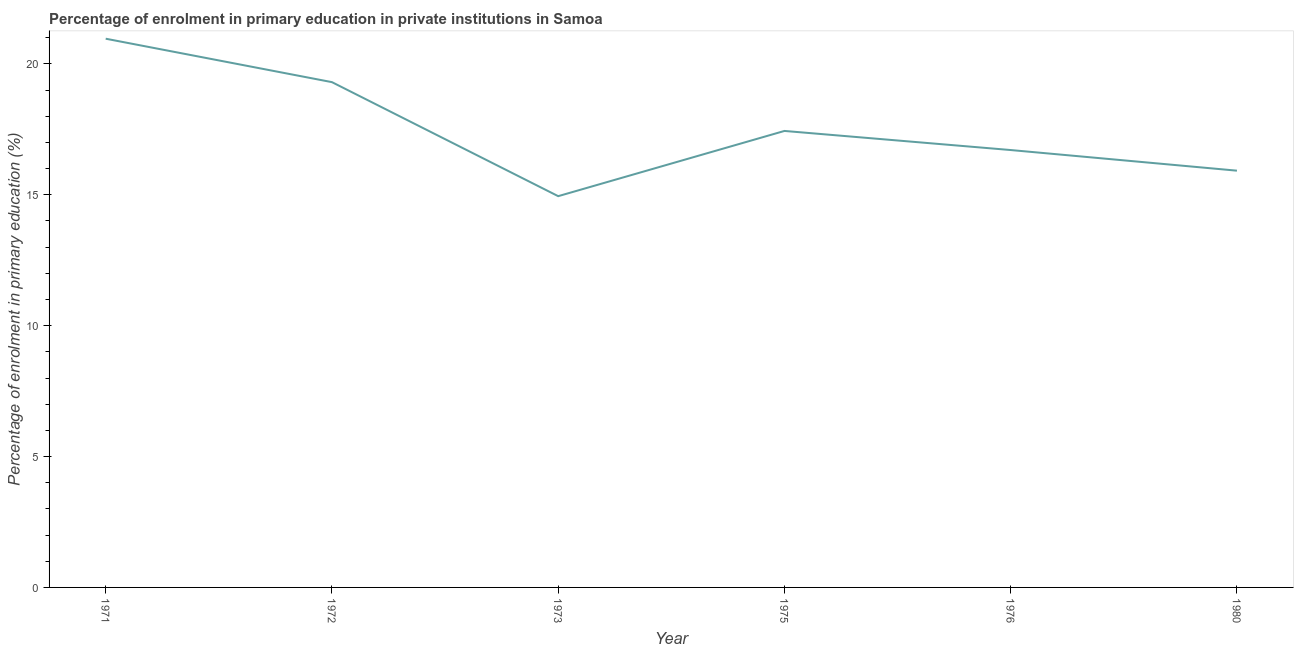What is the enrolment percentage in primary education in 1975?
Keep it short and to the point. 17.44. Across all years, what is the maximum enrolment percentage in primary education?
Provide a short and direct response. 20.96. Across all years, what is the minimum enrolment percentage in primary education?
Offer a terse response. 14.95. In which year was the enrolment percentage in primary education maximum?
Offer a very short reply. 1971. What is the sum of the enrolment percentage in primary education?
Your response must be concise. 105.29. What is the difference between the enrolment percentage in primary education in 1973 and 1980?
Ensure brevity in your answer.  -0.97. What is the average enrolment percentage in primary education per year?
Your answer should be very brief. 17.55. What is the median enrolment percentage in primary education?
Keep it short and to the point. 17.08. What is the ratio of the enrolment percentage in primary education in 1972 to that in 1980?
Your answer should be compact. 1.21. Is the enrolment percentage in primary education in 1972 less than that in 1980?
Provide a succinct answer. No. What is the difference between the highest and the second highest enrolment percentage in primary education?
Your response must be concise. 1.66. Is the sum of the enrolment percentage in primary education in 1972 and 1980 greater than the maximum enrolment percentage in primary education across all years?
Offer a terse response. Yes. What is the difference between the highest and the lowest enrolment percentage in primary education?
Offer a very short reply. 6.02. How many lines are there?
Your response must be concise. 1. Are the values on the major ticks of Y-axis written in scientific E-notation?
Keep it short and to the point. No. What is the title of the graph?
Give a very brief answer. Percentage of enrolment in primary education in private institutions in Samoa. What is the label or title of the Y-axis?
Provide a short and direct response. Percentage of enrolment in primary education (%). What is the Percentage of enrolment in primary education (%) in 1971?
Ensure brevity in your answer.  20.96. What is the Percentage of enrolment in primary education (%) in 1972?
Make the answer very short. 19.3. What is the Percentage of enrolment in primary education (%) of 1973?
Provide a short and direct response. 14.95. What is the Percentage of enrolment in primary education (%) of 1975?
Offer a very short reply. 17.44. What is the Percentage of enrolment in primary education (%) of 1976?
Make the answer very short. 16.71. What is the Percentage of enrolment in primary education (%) in 1980?
Provide a short and direct response. 15.92. What is the difference between the Percentage of enrolment in primary education (%) in 1971 and 1972?
Ensure brevity in your answer.  1.66. What is the difference between the Percentage of enrolment in primary education (%) in 1971 and 1973?
Provide a succinct answer. 6.02. What is the difference between the Percentage of enrolment in primary education (%) in 1971 and 1975?
Your answer should be compact. 3.52. What is the difference between the Percentage of enrolment in primary education (%) in 1971 and 1976?
Offer a terse response. 4.25. What is the difference between the Percentage of enrolment in primary education (%) in 1971 and 1980?
Provide a succinct answer. 5.04. What is the difference between the Percentage of enrolment in primary education (%) in 1972 and 1973?
Provide a succinct answer. 4.36. What is the difference between the Percentage of enrolment in primary education (%) in 1972 and 1975?
Make the answer very short. 1.86. What is the difference between the Percentage of enrolment in primary education (%) in 1972 and 1976?
Your answer should be compact. 2.59. What is the difference between the Percentage of enrolment in primary education (%) in 1972 and 1980?
Provide a short and direct response. 3.38. What is the difference between the Percentage of enrolment in primary education (%) in 1973 and 1975?
Make the answer very short. -2.49. What is the difference between the Percentage of enrolment in primary education (%) in 1973 and 1976?
Make the answer very short. -1.76. What is the difference between the Percentage of enrolment in primary education (%) in 1973 and 1980?
Your answer should be very brief. -0.97. What is the difference between the Percentage of enrolment in primary education (%) in 1975 and 1976?
Make the answer very short. 0.73. What is the difference between the Percentage of enrolment in primary education (%) in 1975 and 1980?
Give a very brief answer. 1.52. What is the difference between the Percentage of enrolment in primary education (%) in 1976 and 1980?
Provide a succinct answer. 0.79. What is the ratio of the Percentage of enrolment in primary education (%) in 1971 to that in 1972?
Your answer should be compact. 1.09. What is the ratio of the Percentage of enrolment in primary education (%) in 1971 to that in 1973?
Keep it short and to the point. 1.4. What is the ratio of the Percentage of enrolment in primary education (%) in 1971 to that in 1975?
Keep it short and to the point. 1.2. What is the ratio of the Percentage of enrolment in primary education (%) in 1971 to that in 1976?
Offer a very short reply. 1.25. What is the ratio of the Percentage of enrolment in primary education (%) in 1971 to that in 1980?
Offer a terse response. 1.32. What is the ratio of the Percentage of enrolment in primary education (%) in 1972 to that in 1973?
Make the answer very short. 1.29. What is the ratio of the Percentage of enrolment in primary education (%) in 1972 to that in 1975?
Provide a short and direct response. 1.11. What is the ratio of the Percentage of enrolment in primary education (%) in 1972 to that in 1976?
Ensure brevity in your answer.  1.16. What is the ratio of the Percentage of enrolment in primary education (%) in 1972 to that in 1980?
Keep it short and to the point. 1.21. What is the ratio of the Percentage of enrolment in primary education (%) in 1973 to that in 1975?
Provide a succinct answer. 0.86. What is the ratio of the Percentage of enrolment in primary education (%) in 1973 to that in 1976?
Your answer should be very brief. 0.9. What is the ratio of the Percentage of enrolment in primary education (%) in 1973 to that in 1980?
Provide a succinct answer. 0.94. What is the ratio of the Percentage of enrolment in primary education (%) in 1975 to that in 1976?
Give a very brief answer. 1.04. What is the ratio of the Percentage of enrolment in primary education (%) in 1975 to that in 1980?
Your answer should be very brief. 1.09. What is the ratio of the Percentage of enrolment in primary education (%) in 1976 to that in 1980?
Your answer should be very brief. 1.05. 